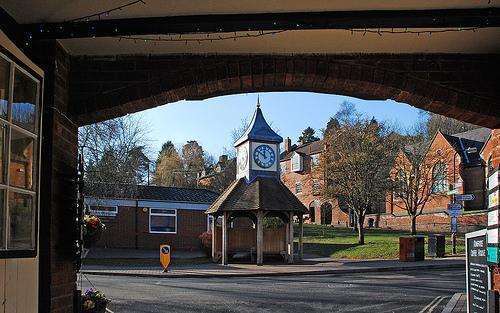How many roman numerals are on the clock?
Give a very brief answer. 12. How many clocks are visible?
Give a very brief answer. 2. 